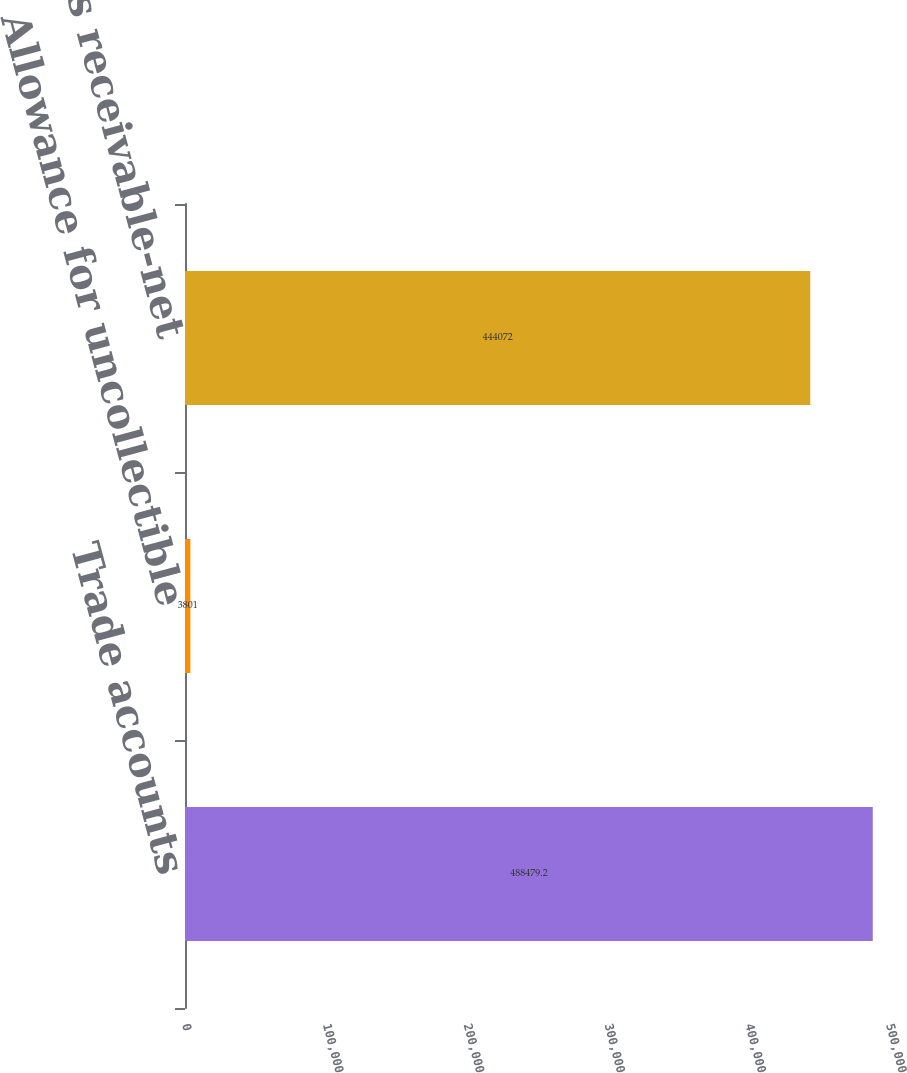Convert chart to OTSL. <chart><loc_0><loc_0><loc_500><loc_500><bar_chart><fcel>Trade accounts<fcel>Allowance for uncollectible<fcel>Trade accounts receivable-net<nl><fcel>488479<fcel>3801<fcel>444072<nl></chart> 